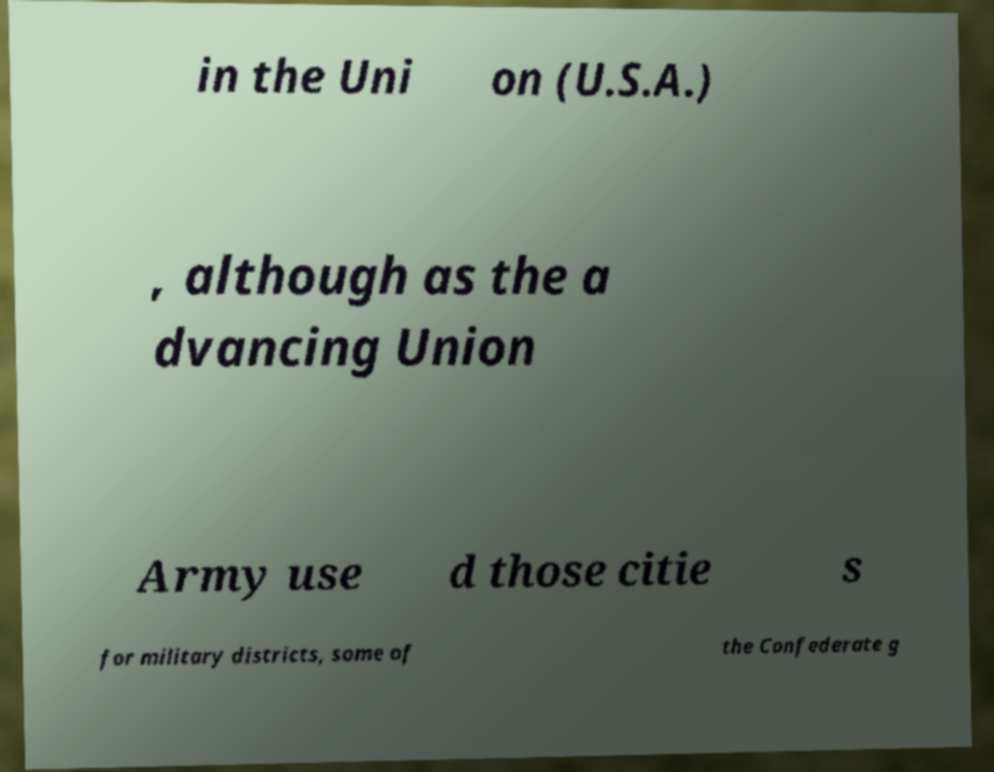Can you accurately transcribe the text from the provided image for me? in the Uni on (U.S.A.) , although as the a dvancing Union Army use d those citie s for military districts, some of the Confederate g 